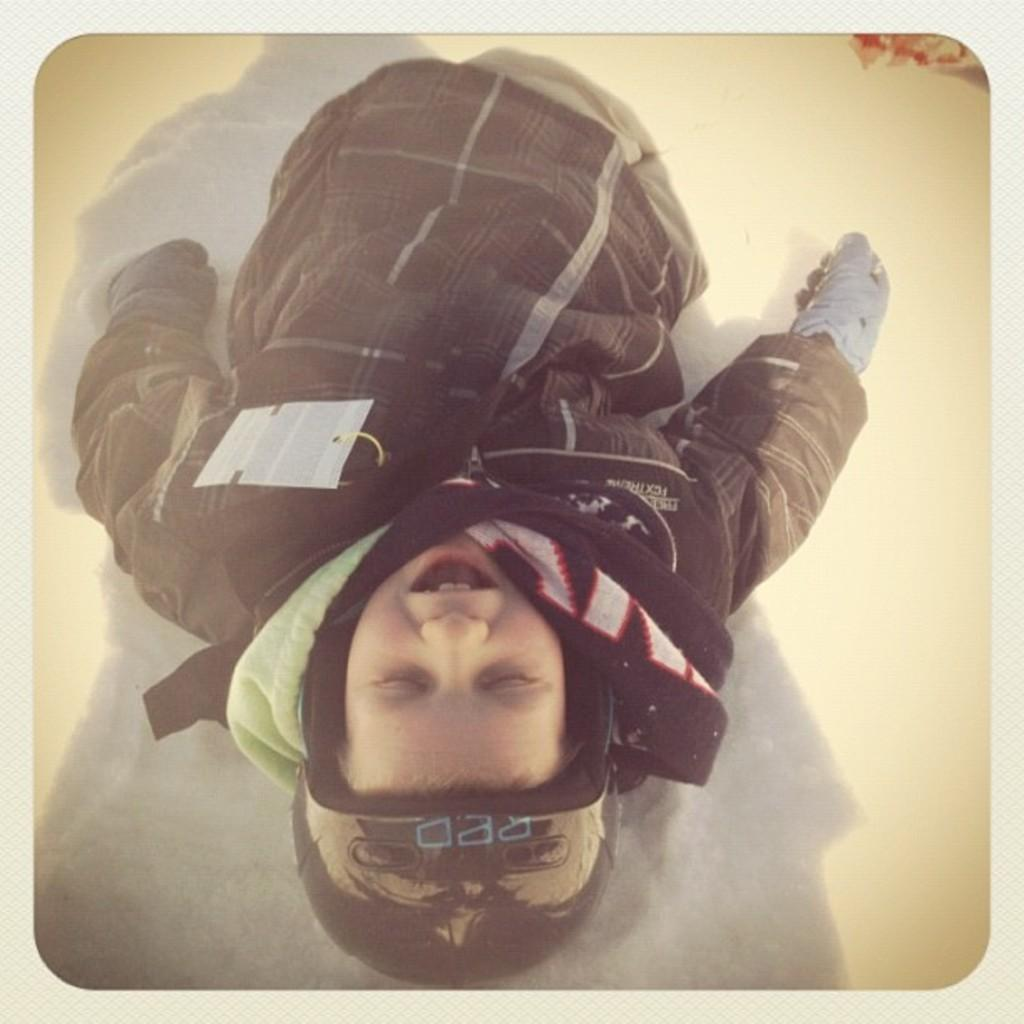Who or what is present in the image? There is a person in the image. What type of clothing is the person wearing? The person is wearing a sweater, gloves, and a cap. What is the person's position in the image? The person is laying on the snow. What type of pail can be seen in the image? There is no pail present in the image. What type of street can be seen in the image? The image does not show a street; it shows a person laying on the snow. 